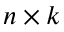<formula> <loc_0><loc_0><loc_500><loc_500>n \times k</formula> 